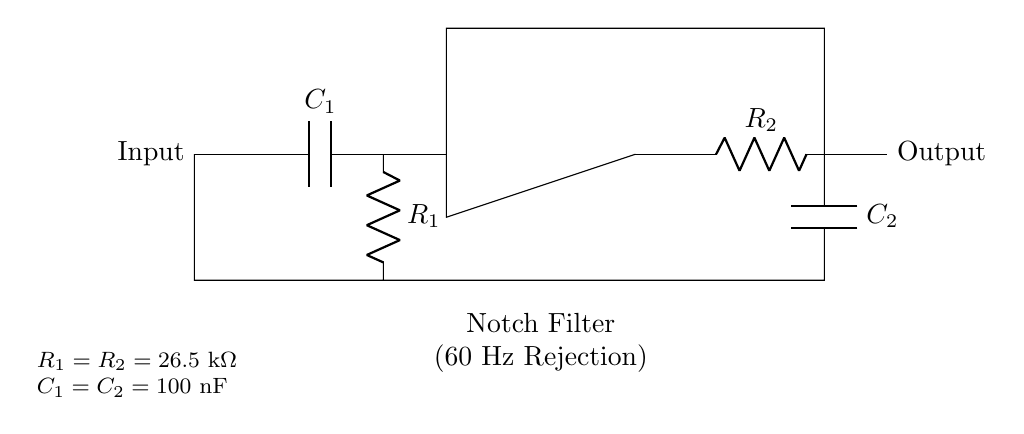What type of filter is represented in the circuit? The circuit showcases a notch filter, specifically designed to reject a specific frequency, in this case, 60 Hz. This is evident from the label in the diagram and the arrangement of components creating alternating high-pass and low-pass characteristics.
Answer: Notch filter What are the values of resistors used in the circuit? The circuit indicates that both resistors are equal, with a resistance value of 26.5 kOhm, as specified in the component values section at the bottom of the diagram.
Answer: 26.5 kOhm How many capacitors are in the circuit? The circuit includes two capacitors, one connected to the high-pass filter section (C1) and the other connected to the low-pass filter section (C2). Both are labeled clearly in the schematic.
Answer: Two What is the purpose of the operational amplifier in this circuit? The operational amplifier in this circuit provides the necessary gain for the signal after filtering, which helps in maintaining the signal integrity after the notch filter effect. It processes the filtered signal and ensures a usable output.
Answer: Signal amplification How does the arrangement of components achieve 60 Hz rejection? The circuit employs a combination of high-pass and low-pass filters that together create a notch filter effect specifically targeting 60 Hz. The capacitors and resistors are configured to create a specific resonance frequency, thereby attenuating signals at 60 Hz while allowing other frequencies to pass through.
Answer: By creating a notch at 60 Hz What are the values of the capacitors used in the circuit? Both capacitors in the circuit, C1 and C2, are set to a value of 100 nanofarads, as indicated in the component values listed below the diagram.
Answer: 100 nanofarads 